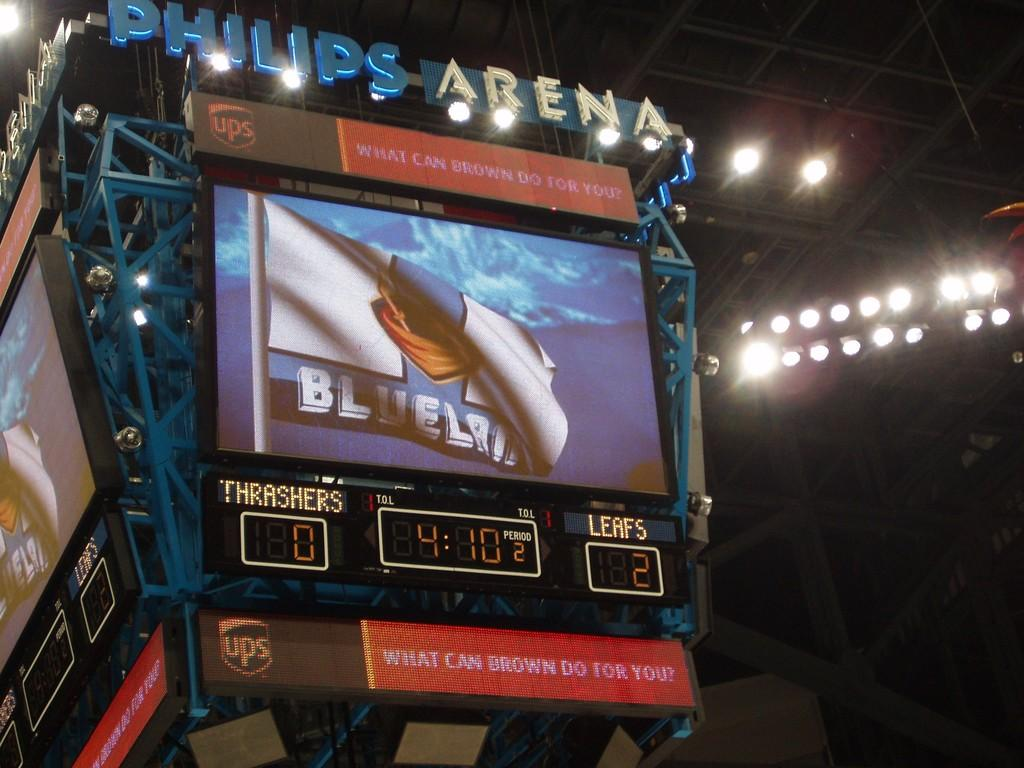<image>
Share a concise interpretation of the image provided. A TV screen which has the word Philips Arena over it. 